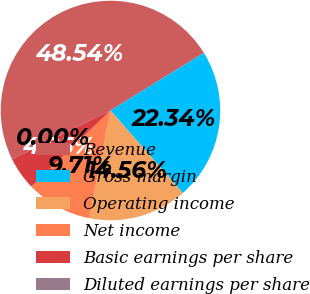Convert chart to OTSL. <chart><loc_0><loc_0><loc_500><loc_500><pie_chart><fcel>Revenue<fcel>Gross margin<fcel>Operating income<fcel>Net income<fcel>Basic earnings per share<fcel>Diluted earnings per share<nl><fcel>48.54%<fcel>22.34%<fcel>14.56%<fcel>9.71%<fcel>4.85%<fcel>0.0%<nl></chart> 